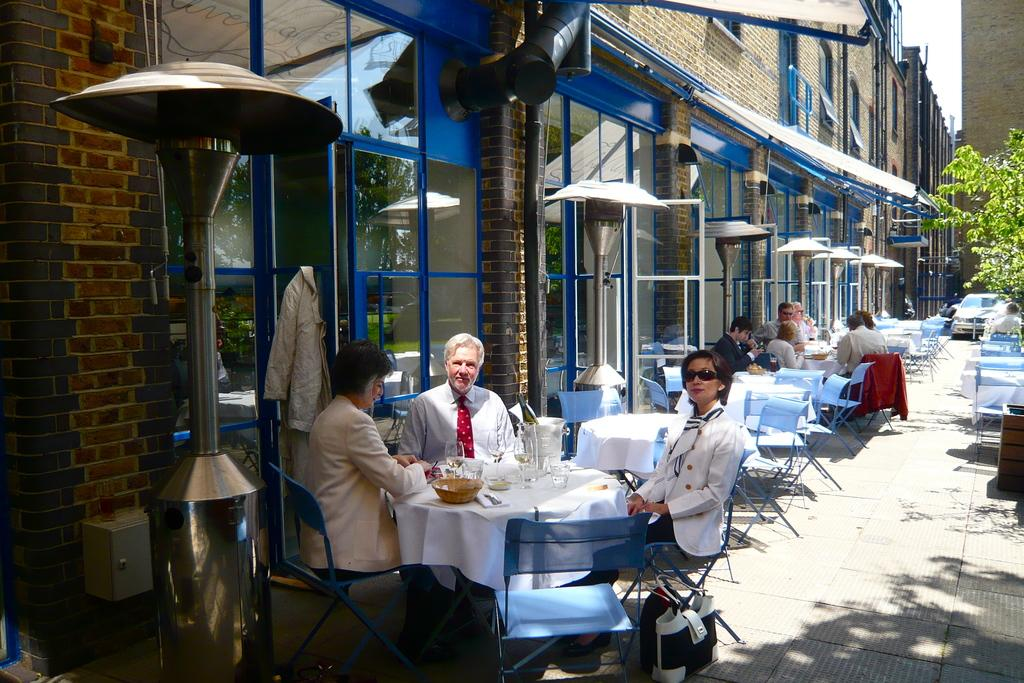What are the people in the image doing? The people in the image are sitting on chairs. What is on the table in the image? There is a bowl, spoons, and napkins on the table. Can you describe the building visible in the image? There is a building visible in the image, but no specific details are provided about its appearance or features. How much does the brick weigh that is not present in the image? There is no brick mentioned or visible in the image, so it is not possible to determine its weight. 